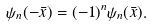<formula> <loc_0><loc_0><loc_500><loc_500>\psi _ { n } ( - \bar { x } ) = ( - 1 ) ^ { n } \psi _ { n } ( \bar { x } ) .</formula> 